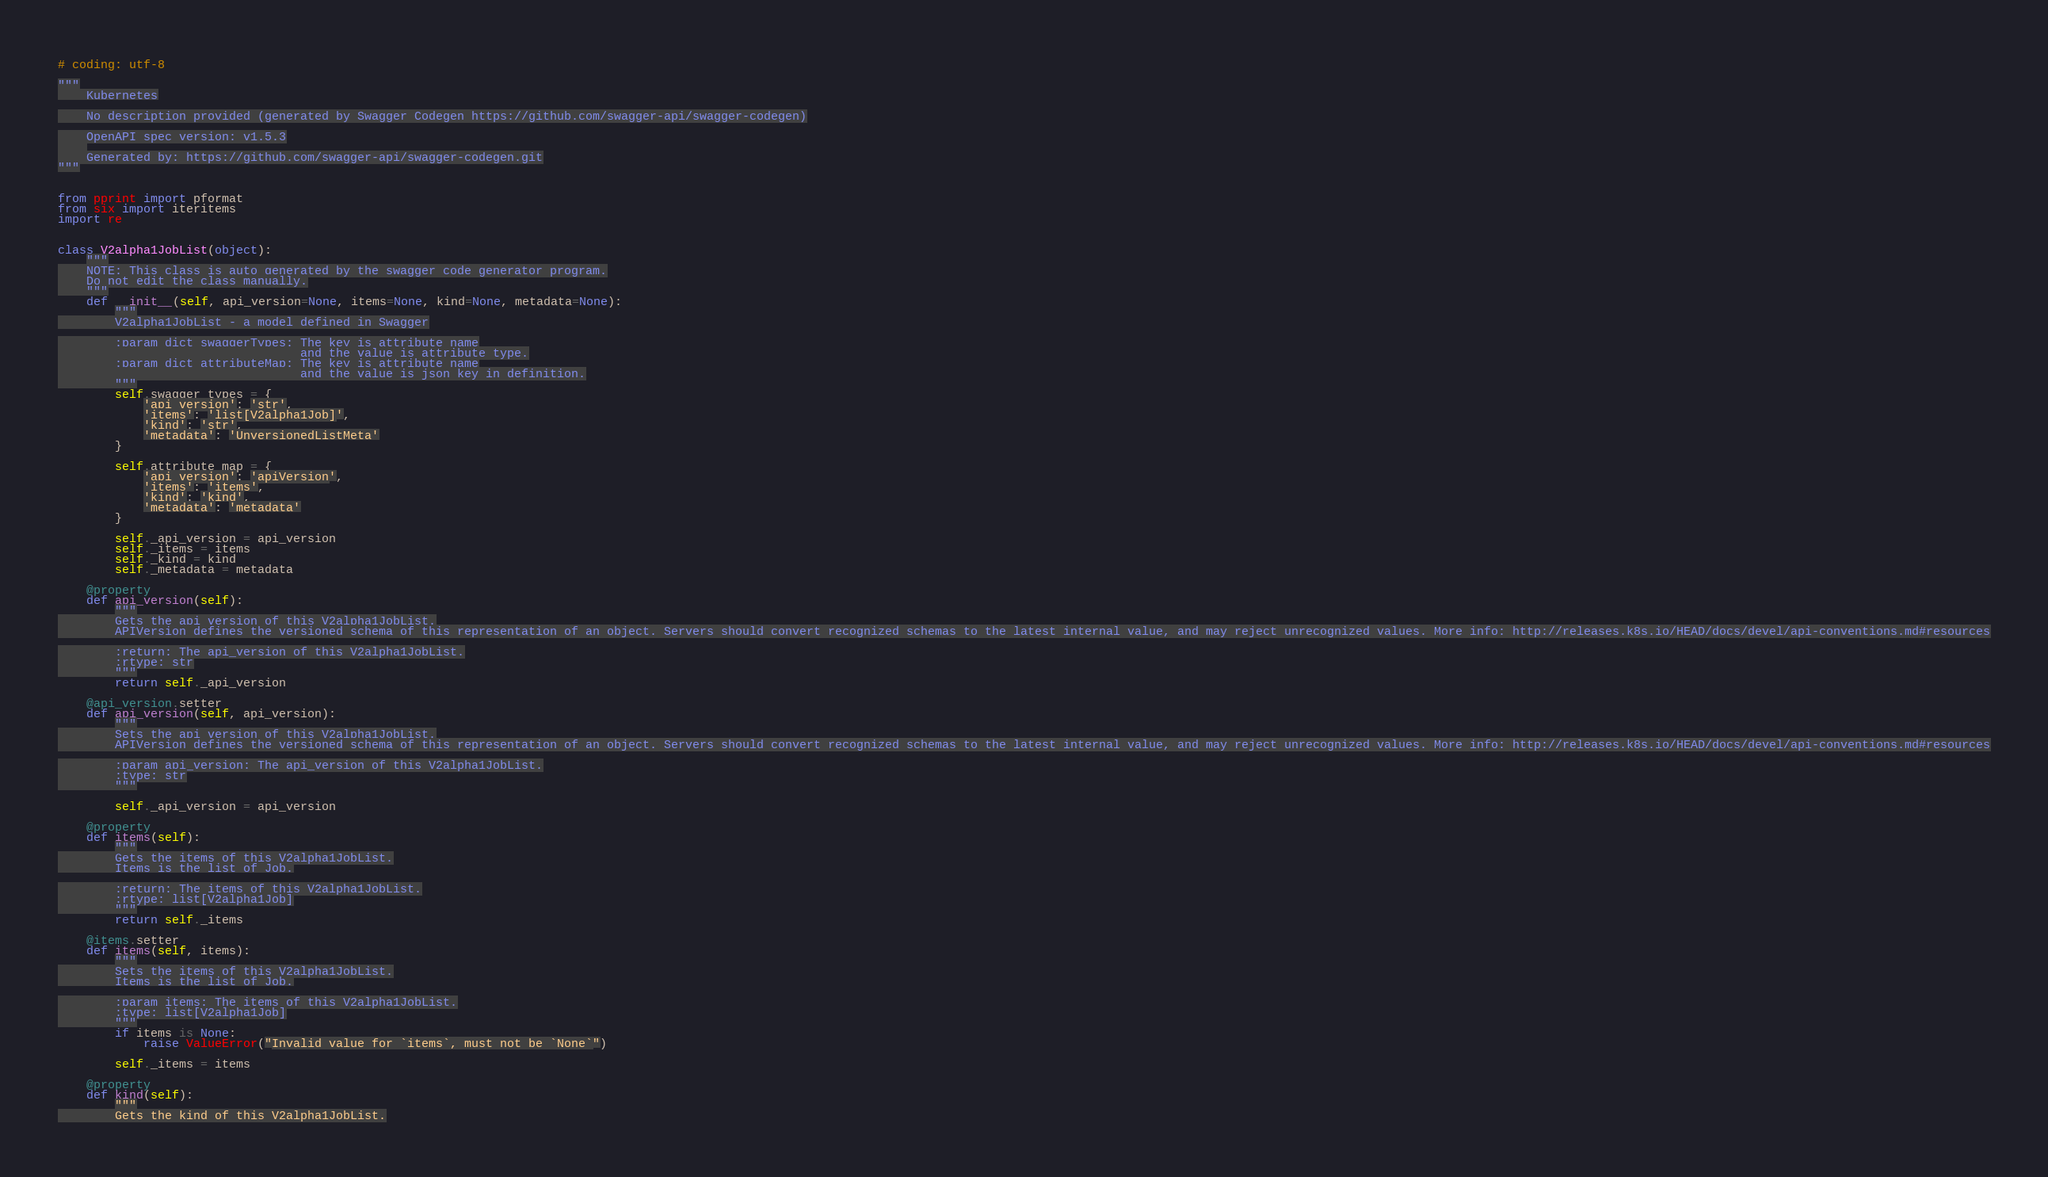<code> <loc_0><loc_0><loc_500><loc_500><_Python_># coding: utf-8

"""
    Kubernetes

    No description provided (generated by Swagger Codegen https://github.com/swagger-api/swagger-codegen)

    OpenAPI spec version: v1.5.3
    
    Generated by: https://github.com/swagger-api/swagger-codegen.git
"""


from pprint import pformat
from six import iteritems
import re


class V2alpha1JobList(object):
    """
    NOTE: This class is auto generated by the swagger code generator program.
    Do not edit the class manually.
    """
    def __init__(self, api_version=None, items=None, kind=None, metadata=None):
        """
        V2alpha1JobList - a model defined in Swagger

        :param dict swaggerTypes: The key is attribute name
                                  and the value is attribute type.
        :param dict attributeMap: The key is attribute name
                                  and the value is json key in definition.
        """
        self.swagger_types = {
            'api_version': 'str',
            'items': 'list[V2alpha1Job]',
            'kind': 'str',
            'metadata': 'UnversionedListMeta'
        }

        self.attribute_map = {
            'api_version': 'apiVersion',
            'items': 'items',
            'kind': 'kind',
            'metadata': 'metadata'
        }

        self._api_version = api_version
        self._items = items
        self._kind = kind
        self._metadata = metadata

    @property
    def api_version(self):
        """
        Gets the api_version of this V2alpha1JobList.
        APIVersion defines the versioned schema of this representation of an object. Servers should convert recognized schemas to the latest internal value, and may reject unrecognized values. More info: http://releases.k8s.io/HEAD/docs/devel/api-conventions.md#resources

        :return: The api_version of this V2alpha1JobList.
        :rtype: str
        """
        return self._api_version

    @api_version.setter
    def api_version(self, api_version):
        """
        Sets the api_version of this V2alpha1JobList.
        APIVersion defines the versioned schema of this representation of an object. Servers should convert recognized schemas to the latest internal value, and may reject unrecognized values. More info: http://releases.k8s.io/HEAD/docs/devel/api-conventions.md#resources

        :param api_version: The api_version of this V2alpha1JobList.
        :type: str
        """

        self._api_version = api_version

    @property
    def items(self):
        """
        Gets the items of this V2alpha1JobList.
        Items is the list of Job.

        :return: The items of this V2alpha1JobList.
        :rtype: list[V2alpha1Job]
        """
        return self._items

    @items.setter
    def items(self, items):
        """
        Sets the items of this V2alpha1JobList.
        Items is the list of Job.

        :param items: The items of this V2alpha1JobList.
        :type: list[V2alpha1Job]
        """
        if items is None:
            raise ValueError("Invalid value for `items`, must not be `None`")

        self._items = items

    @property
    def kind(self):
        """
        Gets the kind of this V2alpha1JobList.</code> 